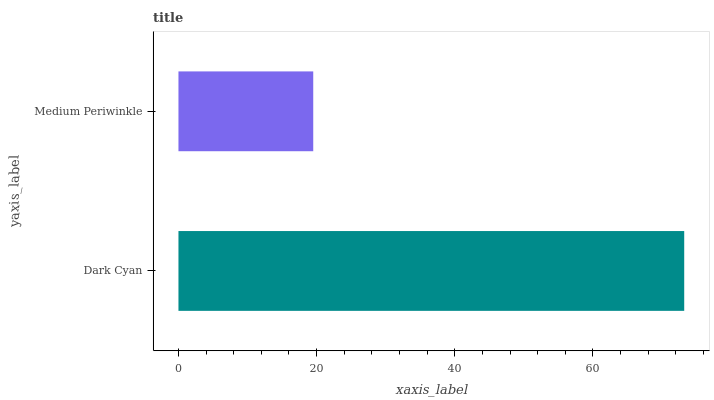Is Medium Periwinkle the minimum?
Answer yes or no. Yes. Is Dark Cyan the maximum?
Answer yes or no. Yes. Is Medium Periwinkle the maximum?
Answer yes or no. No. Is Dark Cyan greater than Medium Periwinkle?
Answer yes or no. Yes. Is Medium Periwinkle less than Dark Cyan?
Answer yes or no. Yes. Is Medium Periwinkle greater than Dark Cyan?
Answer yes or no. No. Is Dark Cyan less than Medium Periwinkle?
Answer yes or no. No. Is Dark Cyan the high median?
Answer yes or no. Yes. Is Medium Periwinkle the low median?
Answer yes or no. Yes. Is Medium Periwinkle the high median?
Answer yes or no. No. Is Dark Cyan the low median?
Answer yes or no. No. 